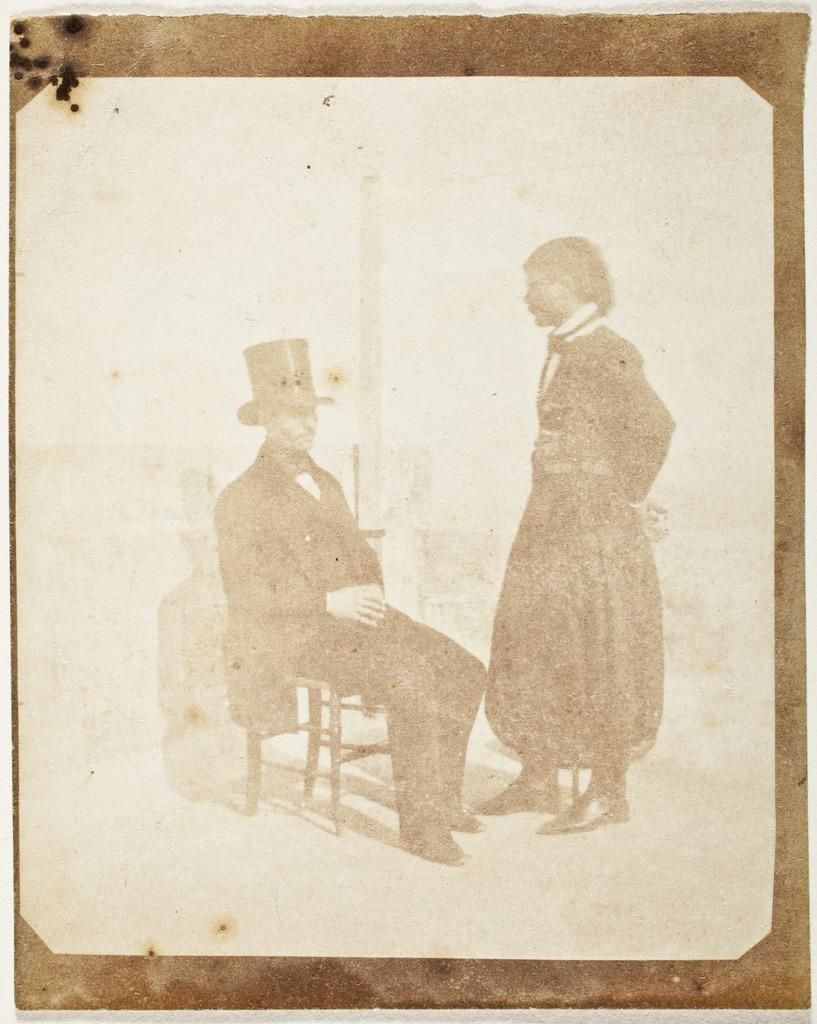What type of visual is depicted in the image? The image is a poster. Can you describe the scene on the poster? There is a person sitting on a chair in the image, and another person is standing in front of the seated person. What type of cushion is the person sitting on in the image? There is no mention of a cushion in the image, as the focus is on the two people and their positions. 